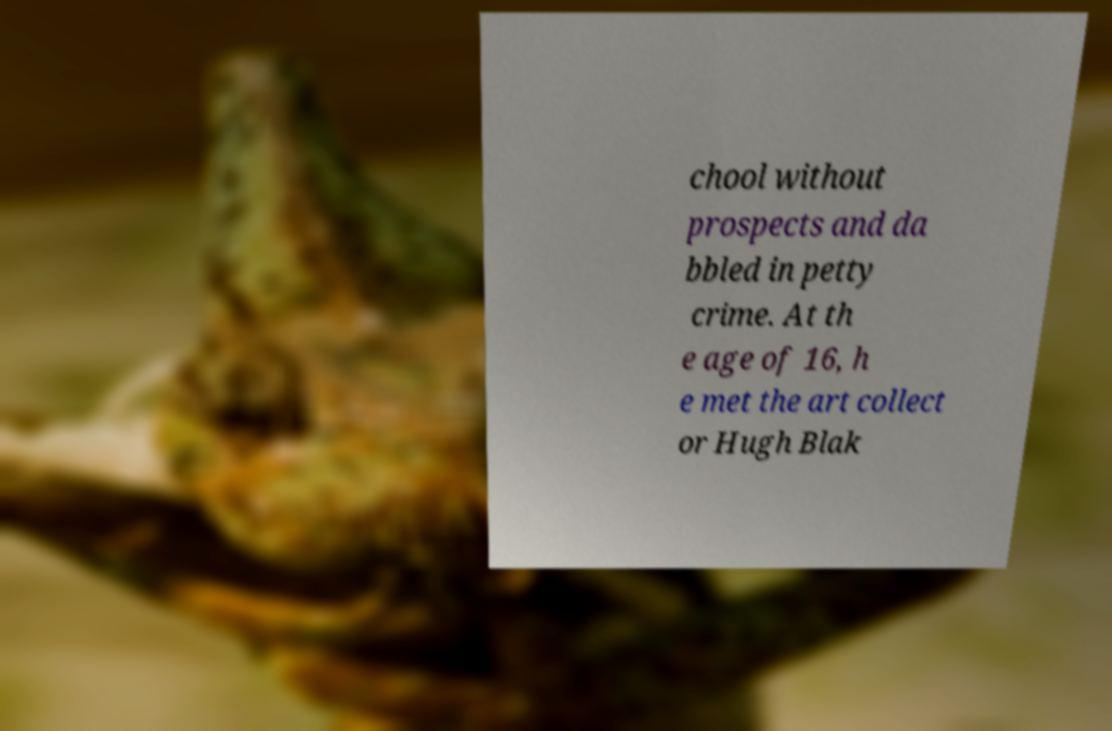I need the written content from this picture converted into text. Can you do that? chool without prospects and da bbled in petty crime. At th e age of 16, h e met the art collect or Hugh Blak 